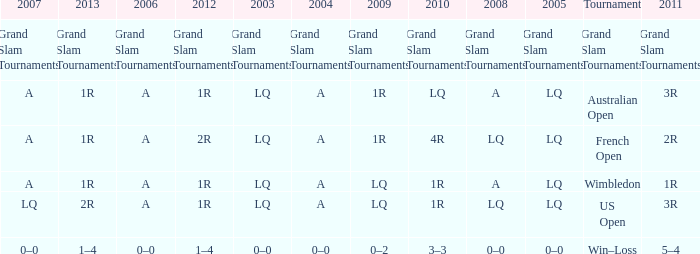Which year has a 2011 of 1r? A. 